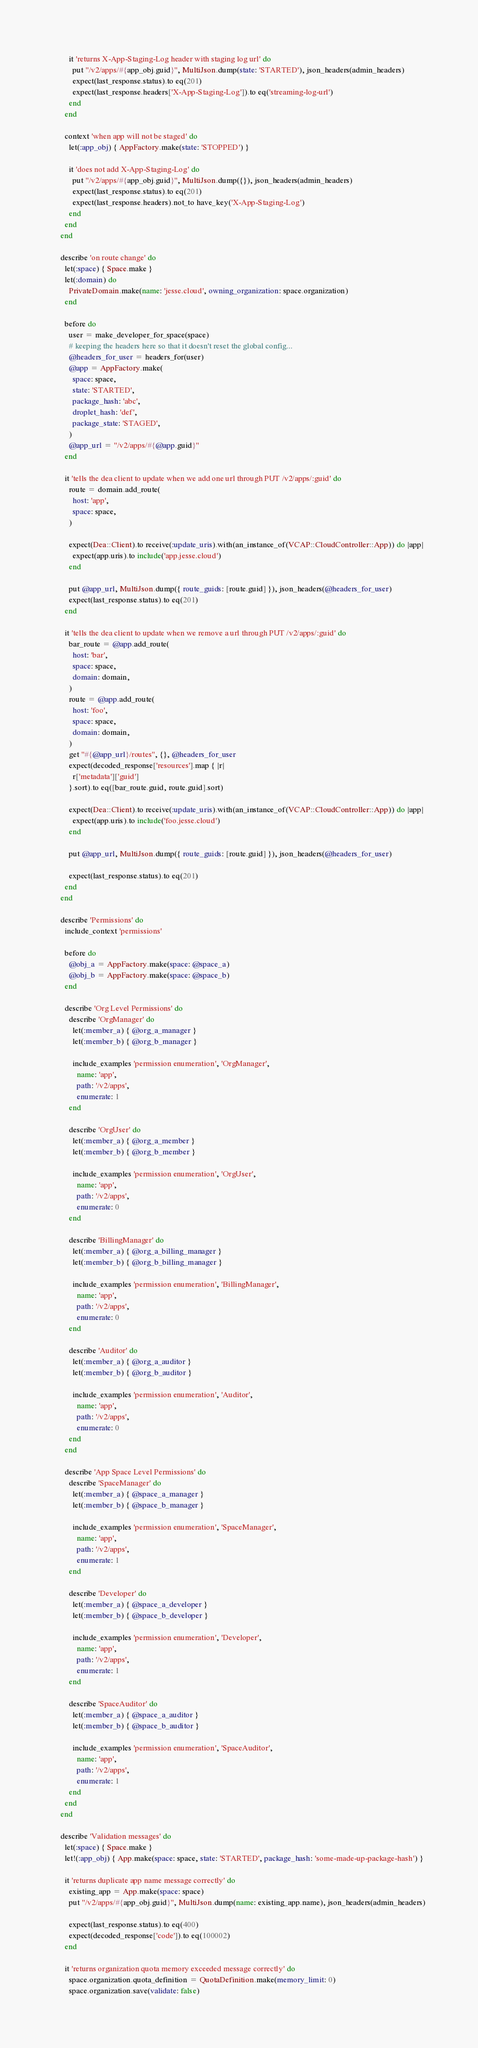<code> <loc_0><loc_0><loc_500><loc_500><_Ruby_>
        it 'returns X-App-Staging-Log header with staging log url' do
          put "/v2/apps/#{app_obj.guid}", MultiJson.dump(state: 'STARTED'), json_headers(admin_headers)
          expect(last_response.status).to eq(201)
          expect(last_response.headers['X-App-Staging-Log']).to eq('streaming-log-url')
        end
      end

      context 'when app will not be staged' do
        let(:app_obj) { AppFactory.make(state: 'STOPPED') }

        it 'does not add X-App-Staging-Log' do
          put "/v2/apps/#{app_obj.guid}", MultiJson.dump({}), json_headers(admin_headers)
          expect(last_response.status).to eq(201)
          expect(last_response.headers).not_to have_key('X-App-Staging-Log')
        end
      end
    end

    describe 'on route change' do
      let(:space) { Space.make }
      let(:domain) do
        PrivateDomain.make(name: 'jesse.cloud', owning_organization: space.organization)
      end

      before do
        user = make_developer_for_space(space)
        # keeping the headers here so that it doesn't reset the global config...
        @headers_for_user = headers_for(user)
        @app = AppFactory.make(
          space: space,
          state: 'STARTED',
          package_hash: 'abc',
          droplet_hash: 'def',
          package_state: 'STAGED',
        )
        @app_url = "/v2/apps/#{@app.guid}"
      end

      it 'tells the dea client to update when we add one url through PUT /v2/apps/:guid' do
        route = domain.add_route(
          host: 'app',
          space: space,
        )

        expect(Dea::Client).to receive(:update_uris).with(an_instance_of(VCAP::CloudController::App)) do |app|
          expect(app.uris).to include('app.jesse.cloud')
        end

        put @app_url, MultiJson.dump({ route_guids: [route.guid] }), json_headers(@headers_for_user)
        expect(last_response.status).to eq(201)
      end

      it 'tells the dea client to update when we remove a url through PUT /v2/apps/:guid' do
        bar_route = @app.add_route(
          host: 'bar',
          space: space,
          domain: domain,
        )
        route = @app.add_route(
          host: 'foo',
          space: space,
          domain: domain,
        )
        get "#{@app_url}/routes", {}, @headers_for_user
        expect(decoded_response['resources'].map { |r|
          r['metadata']['guid']
        }.sort).to eq([bar_route.guid, route.guid].sort)

        expect(Dea::Client).to receive(:update_uris).with(an_instance_of(VCAP::CloudController::App)) do |app|
          expect(app.uris).to include('foo.jesse.cloud')
        end

        put @app_url, MultiJson.dump({ route_guids: [route.guid] }), json_headers(@headers_for_user)

        expect(last_response.status).to eq(201)
      end
    end

    describe 'Permissions' do
      include_context 'permissions'

      before do
        @obj_a = AppFactory.make(space: @space_a)
        @obj_b = AppFactory.make(space: @space_b)
      end

      describe 'Org Level Permissions' do
        describe 'OrgManager' do
          let(:member_a) { @org_a_manager }
          let(:member_b) { @org_b_manager }

          include_examples 'permission enumeration', 'OrgManager',
            name: 'app',
            path: '/v2/apps',
            enumerate: 1
        end

        describe 'OrgUser' do
          let(:member_a) { @org_a_member }
          let(:member_b) { @org_b_member }

          include_examples 'permission enumeration', 'OrgUser',
            name: 'app',
            path: '/v2/apps',
            enumerate: 0
        end

        describe 'BillingManager' do
          let(:member_a) { @org_a_billing_manager }
          let(:member_b) { @org_b_billing_manager }

          include_examples 'permission enumeration', 'BillingManager',
            name: 'app',
            path: '/v2/apps',
            enumerate: 0
        end

        describe 'Auditor' do
          let(:member_a) { @org_a_auditor }
          let(:member_b) { @org_b_auditor }

          include_examples 'permission enumeration', 'Auditor',
            name: 'app',
            path: '/v2/apps',
            enumerate: 0
        end
      end

      describe 'App Space Level Permissions' do
        describe 'SpaceManager' do
          let(:member_a) { @space_a_manager }
          let(:member_b) { @space_b_manager }

          include_examples 'permission enumeration', 'SpaceManager',
            name: 'app',
            path: '/v2/apps',
            enumerate: 1
        end

        describe 'Developer' do
          let(:member_a) { @space_a_developer }
          let(:member_b) { @space_b_developer }

          include_examples 'permission enumeration', 'Developer',
            name: 'app',
            path: '/v2/apps',
            enumerate: 1
        end

        describe 'SpaceAuditor' do
          let(:member_a) { @space_a_auditor }
          let(:member_b) { @space_b_auditor }

          include_examples 'permission enumeration', 'SpaceAuditor',
            name: 'app',
            path: '/v2/apps',
            enumerate: 1
        end
      end
    end

    describe 'Validation messages' do
      let(:space) { Space.make }
      let!(:app_obj) { App.make(space: space, state: 'STARTED', package_hash: 'some-made-up-package-hash') }

      it 'returns duplicate app name message correctly' do
        existing_app = App.make(space: space)
        put "/v2/apps/#{app_obj.guid}", MultiJson.dump(name: existing_app.name), json_headers(admin_headers)

        expect(last_response.status).to eq(400)
        expect(decoded_response['code']).to eq(100002)
      end

      it 'returns organization quota memory exceeded message correctly' do
        space.organization.quota_definition = QuotaDefinition.make(memory_limit: 0)
        space.organization.save(validate: false)
</code> 